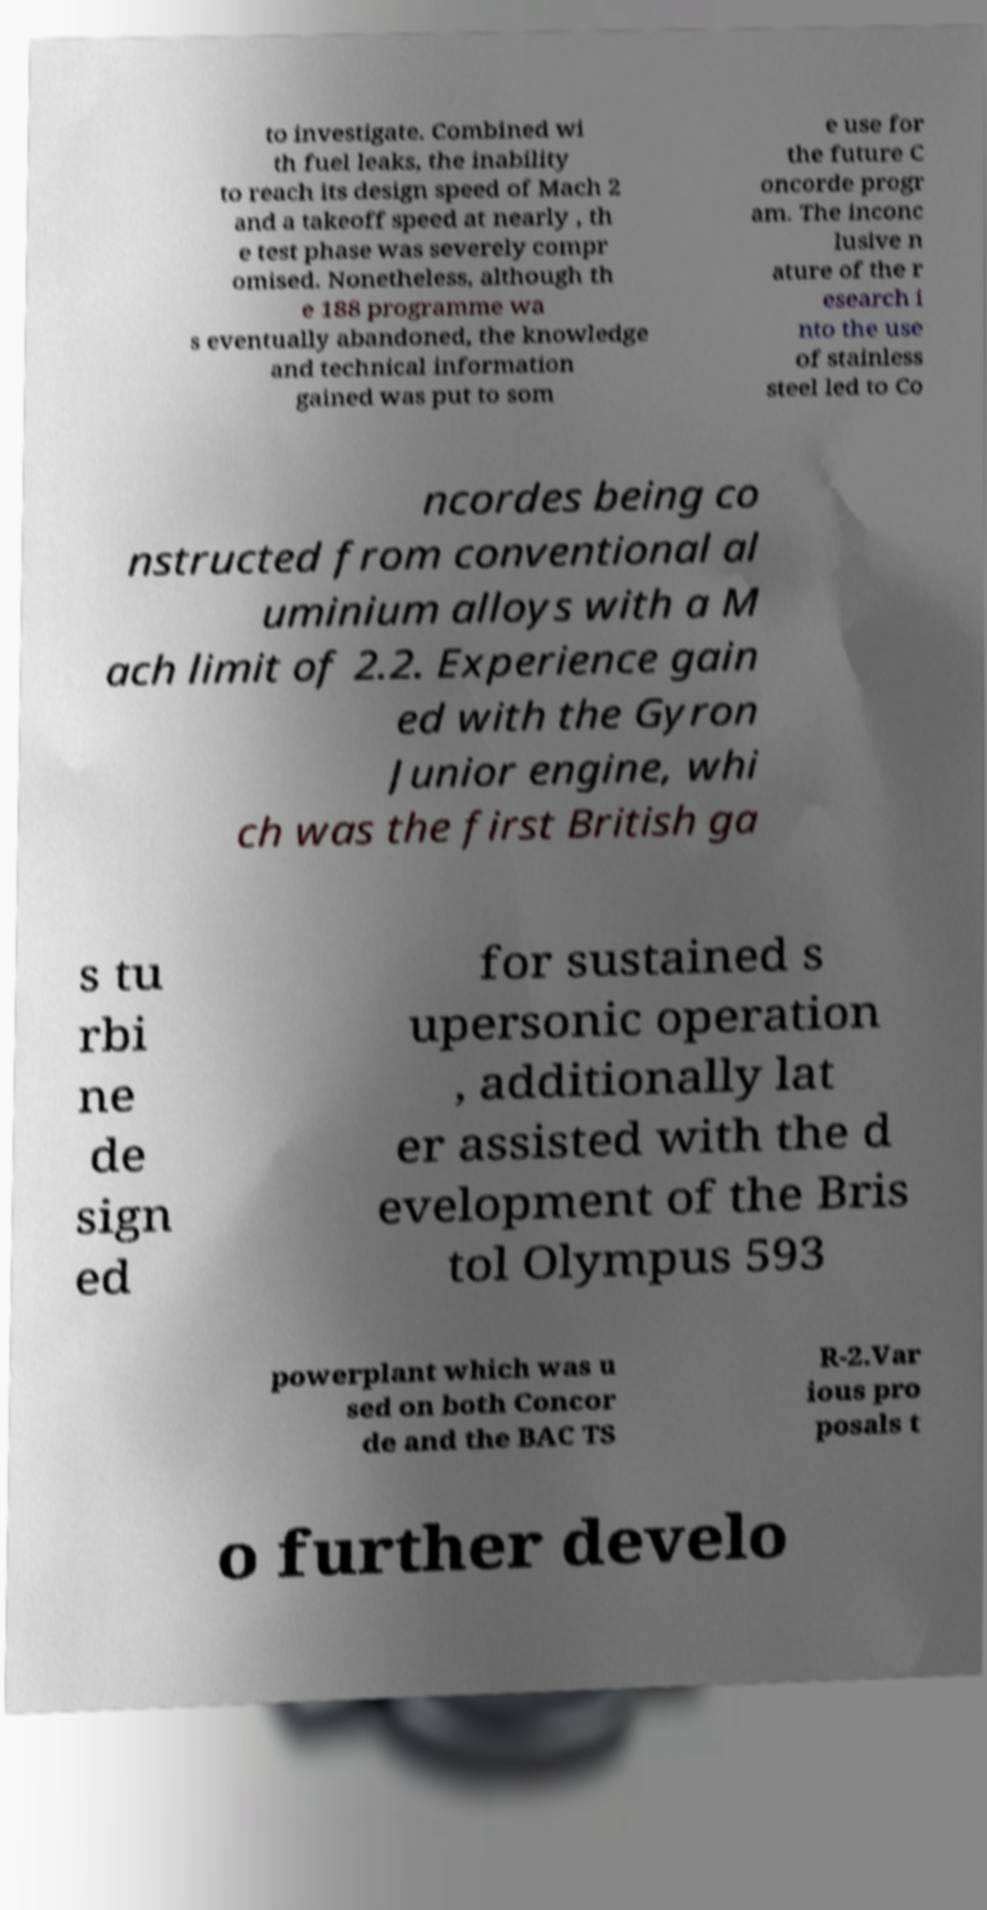Could you extract and type out the text from this image? to investigate. Combined wi th fuel leaks, the inability to reach its design speed of Mach 2 and a takeoff speed at nearly , th e test phase was severely compr omised. Nonetheless, although th e 188 programme wa s eventually abandoned, the knowledge and technical information gained was put to som e use for the future C oncorde progr am. The inconc lusive n ature of the r esearch i nto the use of stainless steel led to Co ncordes being co nstructed from conventional al uminium alloys with a M ach limit of 2.2. Experience gain ed with the Gyron Junior engine, whi ch was the first British ga s tu rbi ne de sign ed for sustained s upersonic operation , additionally lat er assisted with the d evelopment of the Bris tol Olympus 593 powerplant which was u sed on both Concor de and the BAC TS R-2.Var ious pro posals t o further develo 